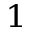Convert formula to latex. <formula><loc_0><loc_0><loc_500><loc_500>^ { 1 }</formula> 